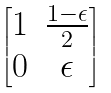Convert formula to latex. <formula><loc_0><loc_0><loc_500><loc_500>\begin{bmatrix} 1 & \frac { 1 - \epsilon } { 2 } \\ 0 & \epsilon \end{bmatrix}</formula> 